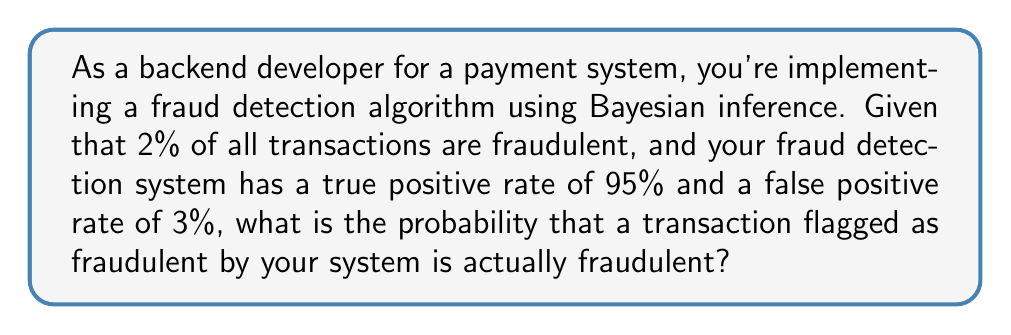Give your solution to this math problem. Let's approach this step-by-step using Bayes' theorem:

1) Define our events:
   F: The transaction is fraudulent
   P: The transaction is flagged as positive (fraudulent) by the system

2) Given information:
   P(F) = 0.02 (prior probability of fraud)
   P(P|F) = 0.95 (true positive rate)
   P(P|not F) = 0.03 (false positive rate)

3) We want to find P(F|P) using Bayes' theorem:

   $$P(F|P) = \frac{P(P|F) \cdot P(F)}{P(P)}$$

4) We need to calculate P(P) using the law of total probability:

   $$P(P) = P(P|F) \cdot P(F) + P(P|\text{not }F) \cdot P(\text{not }F)$$

5) Calculate P(not F):
   P(not F) = 1 - P(F) = 1 - 0.02 = 0.98

6) Now we can calculate P(P):

   $$P(P) = 0.95 \cdot 0.02 + 0.03 \cdot 0.98 = 0.019 + 0.0294 = 0.0484$$

7) Finally, we can apply Bayes' theorem:

   $$P(F|P) = \frac{0.95 \cdot 0.02}{0.0484} = \frac{0.019}{0.0484} \approx 0.3926$$

8) Convert to percentage: 0.3926 * 100 ≈ 39.26%
Answer: 39.26% 